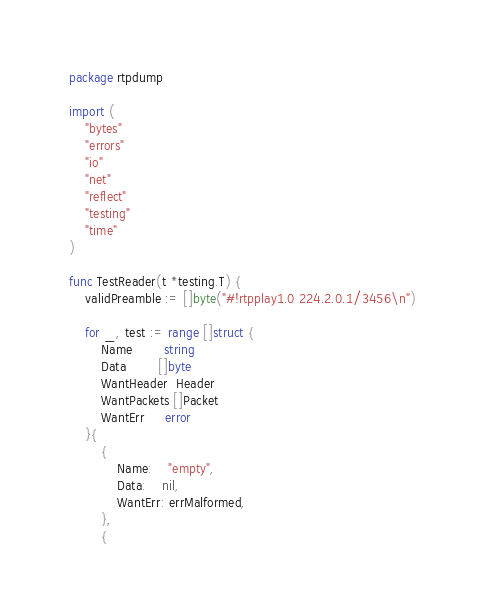<code> <loc_0><loc_0><loc_500><loc_500><_Go_>package rtpdump

import (
	"bytes"
	"errors"
	"io"
	"net"
	"reflect"
	"testing"
	"time"
)

func TestReader(t *testing.T) {
	validPreamble := []byte("#!rtpplay1.0 224.2.0.1/3456\n")

	for _, test := range []struct {
		Name        string
		Data        []byte
		WantHeader  Header
		WantPackets []Packet
		WantErr     error
	}{
		{
			Name:    "empty",
			Data:    nil,
			WantErr: errMalformed,
		},
		{</code> 